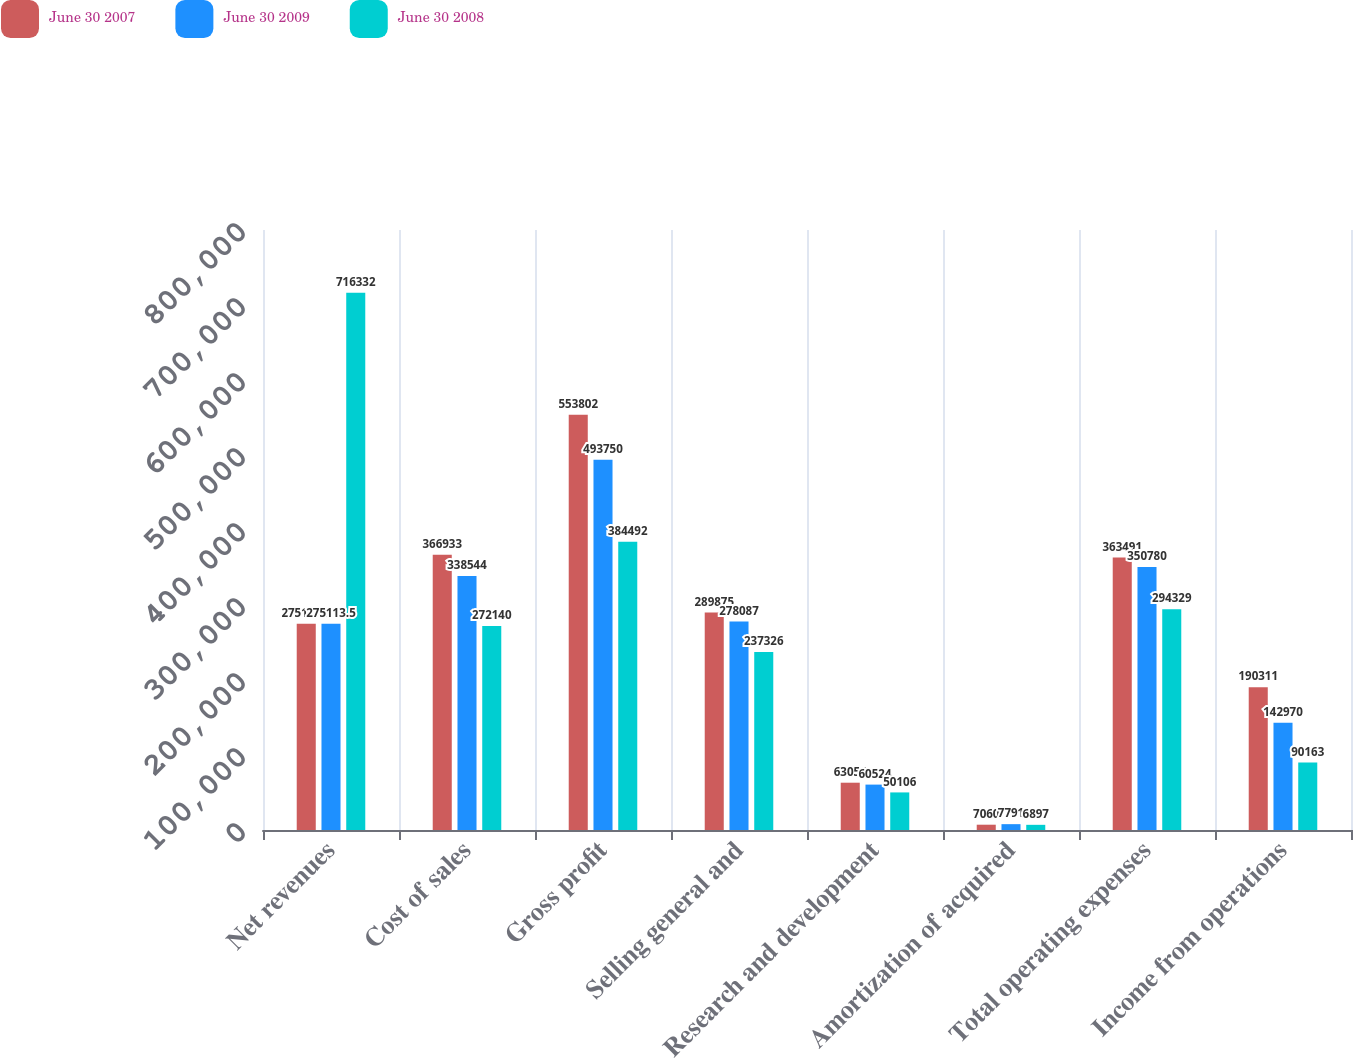Convert chart. <chart><loc_0><loc_0><loc_500><loc_500><stacked_bar_chart><ecel><fcel>Net revenues<fcel>Cost of sales<fcel>Gross profit<fcel>Selling general and<fcel>Research and development<fcel>Amortization of acquired<fcel>Total operating expenses<fcel>Income from operations<nl><fcel>June 30 2007<fcel>275114<fcel>366933<fcel>553802<fcel>289875<fcel>63056<fcel>7060<fcel>363491<fcel>190311<nl><fcel>June 30 2009<fcel>275114<fcel>338544<fcel>493750<fcel>278087<fcel>60524<fcel>7791<fcel>350780<fcel>142970<nl><fcel>June 30 2008<fcel>716332<fcel>272140<fcel>384492<fcel>237326<fcel>50106<fcel>6897<fcel>294329<fcel>90163<nl></chart> 